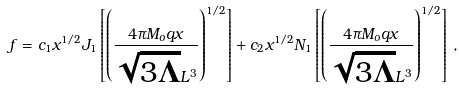Convert formula to latex. <formula><loc_0><loc_0><loc_500><loc_500>\ f = c _ { 1 } x ^ { 1 / 2 } J _ { 1 } \left [ \left ( \frac { 4 \pi M _ { o } q x } { \sqrt { 3 \Lambda } L ^ { 3 } } \right ) ^ { 1 / 2 } \right ] + c _ { 2 } x ^ { 1 / 2 } N _ { 1 } \left [ \left ( \frac { 4 \pi M _ { o } q x } { \sqrt { 3 \Lambda } L ^ { 3 } } \right ) ^ { 1 / 2 } \right ] \, ,</formula> 